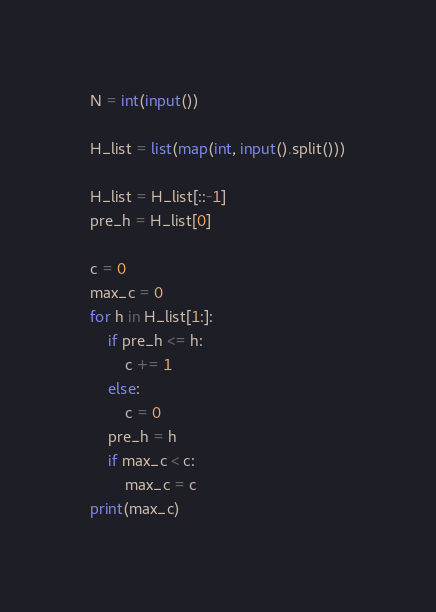<code> <loc_0><loc_0><loc_500><loc_500><_Python_>N = int(input())

H_list = list(map(int, input().split()))

H_list = H_list[::-1]
pre_h = H_list[0]

c = 0
max_c = 0
for h in H_list[1:]:
    if pre_h <= h:
        c += 1
    else:
        c = 0
    pre_h = h
    if max_c < c:
        max_c = c
print(max_c)</code> 